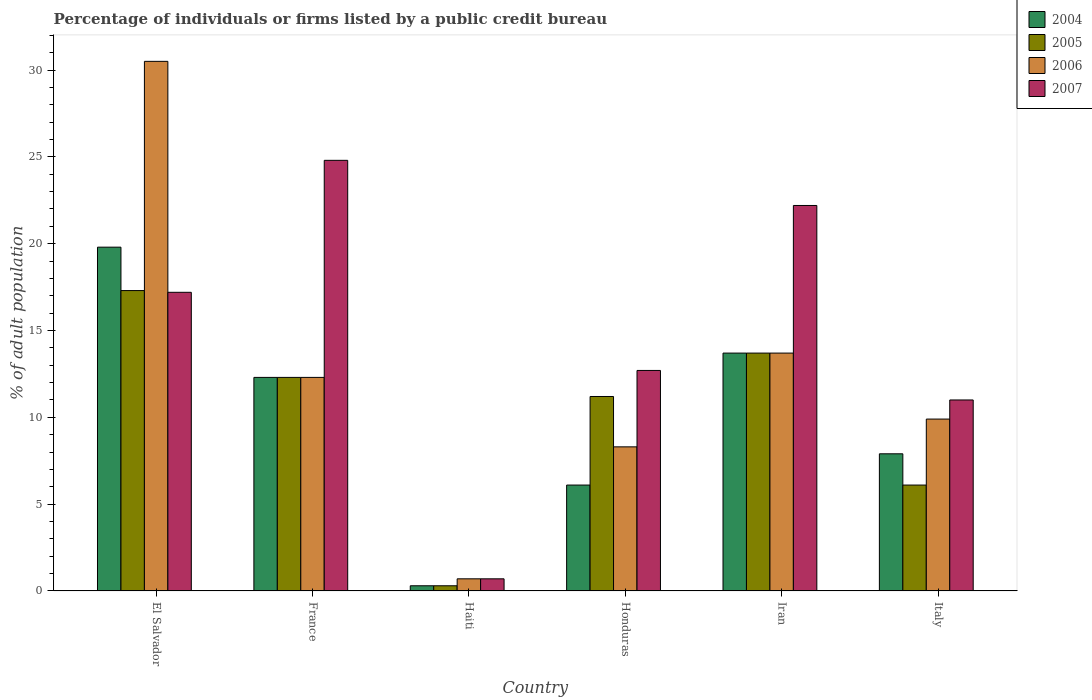How many different coloured bars are there?
Provide a short and direct response. 4. How many groups of bars are there?
Give a very brief answer. 6. What is the label of the 1st group of bars from the left?
Offer a very short reply. El Salvador. In how many cases, is the number of bars for a given country not equal to the number of legend labels?
Provide a short and direct response. 0. What is the percentage of population listed by a public credit bureau in 2004 in Iran?
Ensure brevity in your answer.  13.7. Across all countries, what is the maximum percentage of population listed by a public credit bureau in 2004?
Your answer should be very brief. 19.8. Across all countries, what is the minimum percentage of population listed by a public credit bureau in 2005?
Make the answer very short. 0.3. In which country was the percentage of population listed by a public credit bureau in 2004 maximum?
Give a very brief answer. El Salvador. In which country was the percentage of population listed by a public credit bureau in 2004 minimum?
Provide a succinct answer. Haiti. What is the total percentage of population listed by a public credit bureau in 2004 in the graph?
Make the answer very short. 60.1. What is the difference between the percentage of population listed by a public credit bureau in 2007 in Haiti and that in Honduras?
Your response must be concise. -12. What is the difference between the percentage of population listed by a public credit bureau in 2006 in Honduras and the percentage of population listed by a public credit bureau in 2007 in Italy?
Keep it short and to the point. -2.7. What is the average percentage of population listed by a public credit bureau in 2004 per country?
Provide a succinct answer. 10.02. What is the ratio of the percentage of population listed by a public credit bureau in 2004 in El Salvador to that in Iran?
Offer a terse response. 1.45. Is the difference between the percentage of population listed by a public credit bureau in 2007 in El Salvador and Haiti greater than the difference between the percentage of population listed by a public credit bureau in 2005 in El Salvador and Haiti?
Your response must be concise. No. What is the difference between the highest and the second highest percentage of population listed by a public credit bureau in 2006?
Ensure brevity in your answer.  -1.4. What is the difference between the highest and the lowest percentage of population listed by a public credit bureau in 2007?
Your answer should be very brief. 24.1. In how many countries, is the percentage of population listed by a public credit bureau in 2006 greater than the average percentage of population listed by a public credit bureau in 2006 taken over all countries?
Offer a very short reply. 2. What does the 2nd bar from the left in Haiti represents?
Keep it short and to the point. 2005. Is it the case that in every country, the sum of the percentage of population listed by a public credit bureau in 2007 and percentage of population listed by a public credit bureau in 2004 is greater than the percentage of population listed by a public credit bureau in 2005?
Give a very brief answer. Yes. How many bars are there?
Offer a terse response. 24. What is the difference between two consecutive major ticks on the Y-axis?
Provide a short and direct response. 5. Does the graph contain any zero values?
Your response must be concise. No. Does the graph contain grids?
Offer a very short reply. No. How many legend labels are there?
Your answer should be very brief. 4. What is the title of the graph?
Offer a terse response. Percentage of individuals or firms listed by a public credit bureau. What is the label or title of the Y-axis?
Your response must be concise. % of adult population. What is the % of adult population in 2004 in El Salvador?
Your answer should be compact. 19.8. What is the % of adult population of 2005 in El Salvador?
Offer a terse response. 17.3. What is the % of adult population of 2006 in El Salvador?
Provide a succinct answer. 30.5. What is the % of adult population in 2007 in El Salvador?
Your answer should be compact. 17.2. What is the % of adult population of 2004 in France?
Offer a very short reply. 12.3. What is the % of adult population in 2006 in France?
Provide a succinct answer. 12.3. What is the % of adult population in 2007 in France?
Your response must be concise. 24.8. What is the % of adult population in 2004 in Haiti?
Your response must be concise. 0.3. What is the % of adult population in 2006 in Haiti?
Your answer should be compact. 0.7. What is the % of adult population in 2007 in Haiti?
Offer a terse response. 0.7. What is the % of adult population in 2007 in Honduras?
Provide a short and direct response. 12.7. What is the % of adult population in 2004 in Iran?
Your response must be concise. 13.7. What is the % of adult population of 2007 in Iran?
Give a very brief answer. 22.2. What is the % of adult population in 2006 in Italy?
Your response must be concise. 9.9. Across all countries, what is the maximum % of adult population in 2004?
Provide a succinct answer. 19.8. Across all countries, what is the maximum % of adult population in 2005?
Offer a terse response. 17.3. Across all countries, what is the maximum % of adult population in 2006?
Ensure brevity in your answer.  30.5. Across all countries, what is the maximum % of adult population of 2007?
Provide a succinct answer. 24.8. Across all countries, what is the minimum % of adult population of 2004?
Give a very brief answer. 0.3. Across all countries, what is the minimum % of adult population of 2005?
Your answer should be very brief. 0.3. What is the total % of adult population in 2004 in the graph?
Provide a short and direct response. 60.1. What is the total % of adult population of 2005 in the graph?
Offer a very short reply. 60.9. What is the total % of adult population in 2006 in the graph?
Offer a very short reply. 75.4. What is the total % of adult population of 2007 in the graph?
Make the answer very short. 88.6. What is the difference between the % of adult population in 2004 in El Salvador and that in France?
Keep it short and to the point. 7.5. What is the difference between the % of adult population of 2005 in El Salvador and that in France?
Offer a very short reply. 5. What is the difference between the % of adult population in 2004 in El Salvador and that in Haiti?
Your response must be concise. 19.5. What is the difference between the % of adult population in 2006 in El Salvador and that in Haiti?
Give a very brief answer. 29.8. What is the difference between the % of adult population in 2007 in El Salvador and that in Haiti?
Offer a terse response. 16.5. What is the difference between the % of adult population in 2006 in El Salvador and that in Honduras?
Offer a very short reply. 22.2. What is the difference between the % of adult population of 2004 in El Salvador and that in Iran?
Offer a terse response. 6.1. What is the difference between the % of adult population in 2005 in El Salvador and that in Iran?
Give a very brief answer. 3.6. What is the difference between the % of adult population of 2006 in El Salvador and that in Iran?
Ensure brevity in your answer.  16.8. What is the difference between the % of adult population of 2007 in El Salvador and that in Iran?
Provide a short and direct response. -5. What is the difference between the % of adult population of 2005 in El Salvador and that in Italy?
Provide a short and direct response. 11.2. What is the difference between the % of adult population in 2006 in El Salvador and that in Italy?
Your answer should be compact. 20.6. What is the difference between the % of adult population of 2004 in France and that in Haiti?
Ensure brevity in your answer.  12. What is the difference between the % of adult population in 2005 in France and that in Haiti?
Offer a very short reply. 12. What is the difference between the % of adult population of 2006 in France and that in Haiti?
Your response must be concise. 11.6. What is the difference between the % of adult population of 2007 in France and that in Haiti?
Your response must be concise. 24.1. What is the difference between the % of adult population in 2004 in France and that in Honduras?
Offer a very short reply. 6.2. What is the difference between the % of adult population of 2005 in France and that in Honduras?
Keep it short and to the point. 1.1. What is the difference between the % of adult population of 2007 in France and that in Honduras?
Make the answer very short. 12.1. What is the difference between the % of adult population in 2007 in France and that in Iran?
Your response must be concise. 2.6. What is the difference between the % of adult population of 2004 in France and that in Italy?
Your response must be concise. 4.4. What is the difference between the % of adult population of 2006 in France and that in Italy?
Ensure brevity in your answer.  2.4. What is the difference between the % of adult population in 2004 in Haiti and that in Honduras?
Your answer should be very brief. -5.8. What is the difference between the % of adult population of 2007 in Haiti and that in Honduras?
Ensure brevity in your answer.  -12. What is the difference between the % of adult population in 2004 in Haiti and that in Iran?
Your response must be concise. -13.4. What is the difference between the % of adult population of 2005 in Haiti and that in Iran?
Ensure brevity in your answer.  -13.4. What is the difference between the % of adult population in 2007 in Haiti and that in Iran?
Provide a succinct answer. -21.5. What is the difference between the % of adult population in 2004 in Haiti and that in Italy?
Keep it short and to the point. -7.6. What is the difference between the % of adult population of 2006 in Haiti and that in Italy?
Provide a short and direct response. -9.2. What is the difference between the % of adult population of 2007 in Haiti and that in Italy?
Give a very brief answer. -10.3. What is the difference between the % of adult population in 2004 in Honduras and that in Iran?
Offer a terse response. -7.6. What is the difference between the % of adult population in 2006 in Honduras and that in Iran?
Ensure brevity in your answer.  -5.4. What is the difference between the % of adult population in 2006 in Honduras and that in Italy?
Keep it short and to the point. -1.6. What is the difference between the % of adult population in 2004 in El Salvador and the % of adult population in 2006 in France?
Make the answer very short. 7.5. What is the difference between the % of adult population in 2005 in El Salvador and the % of adult population in 2007 in France?
Offer a terse response. -7.5. What is the difference between the % of adult population of 2004 in El Salvador and the % of adult population of 2005 in Haiti?
Keep it short and to the point. 19.5. What is the difference between the % of adult population of 2004 in El Salvador and the % of adult population of 2006 in Haiti?
Offer a very short reply. 19.1. What is the difference between the % of adult population of 2004 in El Salvador and the % of adult population of 2007 in Haiti?
Ensure brevity in your answer.  19.1. What is the difference between the % of adult population in 2005 in El Salvador and the % of adult population in 2006 in Haiti?
Your answer should be very brief. 16.6. What is the difference between the % of adult population of 2006 in El Salvador and the % of adult population of 2007 in Haiti?
Provide a short and direct response. 29.8. What is the difference between the % of adult population in 2004 in El Salvador and the % of adult population in 2007 in Honduras?
Keep it short and to the point. 7.1. What is the difference between the % of adult population of 2005 in El Salvador and the % of adult population of 2006 in Honduras?
Offer a terse response. 9. What is the difference between the % of adult population in 2006 in El Salvador and the % of adult population in 2007 in Honduras?
Your response must be concise. 17.8. What is the difference between the % of adult population in 2004 in El Salvador and the % of adult population in 2006 in Iran?
Your answer should be compact. 6.1. What is the difference between the % of adult population in 2004 in El Salvador and the % of adult population in 2007 in Iran?
Ensure brevity in your answer.  -2.4. What is the difference between the % of adult population in 2005 in El Salvador and the % of adult population in 2006 in Iran?
Offer a terse response. 3.6. What is the difference between the % of adult population in 2005 in El Salvador and the % of adult population in 2007 in Iran?
Give a very brief answer. -4.9. What is the difference between the % of adult population in 2004 in El Salvador and the % of adult population in 2005 in Italy?
Offer a very short reply. 13.7. What is the difference between the % of adult population in 2004 in El Salvador and the % of adult population in 2006 in Italy?
Keep it short and to the point. 9.9. What is the difference between the % of adult population in 2004 in El Salvador and the % of adult population in 2007 in Italy?
Your response must be concise. 8.8. What is the difference between the % of adult population of 2005 in El Salvador and the % of adult population of 2007 in Italy?
Offer a very short reply. 6.3. What is the difference between the % of adult population of 2004 in France and the % of adult population of 2005 in Haiti?
Your answer should be very brief. 12. What is the difference between the % of adult population in 2004 in France and the % of adult population in 2006 in Haiti?
Ensure brevity in your answer.  11.6. What is the difference between the % of adult population of 2004 in France and the % of adult population of 2007 in Haiti?
Provide a short and direct response. 11.6. What is the difference between the % of adult population of 2005 in France and the % of adult population of 2006 in Haiti?
Your response must be concise. 11.6. What is the difference between the % of adult population of 2005 in France and the % of adult population of 2007 in Haiti?
Your response must be concise. 11.6. What is the difference between the % of adult population in 2004 in France and the % of adult population in 2006 in Honduras?
Give a very brief answer. 4. What is the difference between the % of adult population in 2006 in France and the % of adult population in 2007 in Honduras?
Provide a succinct answer. -0.4. What is the difference between the % of adult population of 2005 in France and the % of adult population of 2006 in Iran?
Your response must be concise. -1.4. What is the difference between the % of adult population of 2005 in France and the % of adult population of 2007 in Iran?
Offer a terse response. -9.9. What is the difference between the % of adult population of 2004 in France and the % of adult population of 2005 in Italy?
Provide a short and direct response. 6.2. What is the difference between the % of adult population in 2005 in France and the % of adult population in 2007 in Italy?
Your response must be concise. 1.3. What is the difference between the % of adult population of 2006 in France and the % of adult population of 2007 in Italy?
Your answer should be compact. 1.3. What is the difference between the % of adult population of 2004 in Haiti and the % of adult population of 2005 in Honduras?
Ensure brevity in your answer.  -10.9. What is the difference between the % of adult population of 2004 in Haiti and the % of adult population of 2006 in Honduras?
Your answer should be very brief. -8. What is the difference between the % of adult population of 2004 in Haiti and the % of adult population of 2007 in Honduras?
Provide a short and direct response. -12.4. What is the difference between the % of adult population in 2005 in Haiti and the % of adult population in 2006 in Honduras?
Provide a short and direct response. -8. What is the difference between the % of adult population of 2005 in Haiti and the % of adult population of 2007 in Honduras?
Keep it short and to the point. -12.4. What is the difference between the % of adult population of 2004 in Haiti and the % of adult population of 2005 in Iran?
Keep it short and to the point. -13.4. What is the difference between the % of adult population in 2004 in Haiti and the % of adult population in 2006 in Iran?
Ensure brevity in your answer.  -13.4. What is the difference between the % of adult population of 2004 in Haiti and the % of adult population of 2007 in Iran?
Provide a short and direct response. -21.9. What is the difference between the % of adult population of 2005 in Haiti and the % of adult population of 2007 in Iran?
Make the answer very short. -21.9. What is the difference between the % of adult population in 2006 in Haiti and the % of adult population in 2007 in Iran?
Give a very brief answer. -21.5. What is the difference between the % of adult population of 2004 in Haiti and the % of adult population of 2006 in Italy?
Keep it short and to the point. -9.6. What is the difference between the % of adult population of 2004 in Haiti and the % of adult population of 2007 in Italy?
Your answer should be very brief. -10.7. What is the difference between the % of adult population in 2004 in Honduras and the % of adult population in 2007 in Iran?
Keep it short and to the point. -16.1. What is the difference between the % of adult population in 2004 in Honduras and the % of adult population in 2007 in Italy?
Give a very brief answer. -4.9. What is the difference between the % of adult population of 2005 in Honduras and the % of adult population of 2006 in Italy?
Your answer should be compact. 1.3. What is the difference between the % of adult population in 2005 in Honduras and the % of adult population in 2007 in Italy?
Your answer should be compact. 0.2. What is the difference between the % of adult population of 2006 in Honduras and the % of adult population of 2007 in Italy?
Offer a terse response. -2.7. What is the difference between the % of adult population of 2005 in Iran and the % of adult population of 2007 in Italy?
Make the answer very short. 2.7. What is the average % of adult population of 2004 per country?
Provide a short and direct response. 10.02. What is the average % of adult population of 2005 per country?
Keep it short and to the point. 10.15. What is the average % of adult population of 2006 per country?
Your answer should be very brief. 12.57. What is the average % of adult population of 2007 per country?
Provide a short and direct response. 14.77. What is the difference between the % of adult population in 2004 and % of adult population in 2005 in El Salvador?
Make the answer very short. 2.5. What is the difference between the % of adult population of 2006 and % of adult population of 2007 in El Salvador?
Your answer should be compact. 13.3. What is the difference between the % of adult population in 2004 and % of adult population in 2005 in France?
Your answer should be very brief. 0. What is the difference between the % of adult population of 2004 and % of adult population of 2006 in France?
Your answer should be very brief. 0. What is the difference between the % of adult population in 2005 and % of adult population in 2006 in France?
Your answer should be very brief. 0. What is the difference between the % of adult population of 2005 and % of adult population of 2007 in France?
Give a very brief answer. -12.5. What is the difference between the % of adult population in 2006 and % of adult population in 2007 in France?
Make the answer very short. -12.5. What is the difference between the % of adult population of 2004 and % of adult population of 2007 in Haiti?
Make the answer very short. -0.4. What is the difference between the % of adult population of 2006 and % of adult population of 2007 in Haiti?
Make the answer very short. 0. What is the difference between the % of adult population in 2004 and % of adult population in 2005 in Honduras?
Give a very brief answer. -5.1. What is the difference between the % of adult population in 2004 and % of adult population in 2006 in Honduras?
Your answer should be very brief. -2.2. What is the difference between the % of adult population of 2004 and % of adult population of 2007 in Honduras?
Give a very brief answer. -6.6. What is the difference between the % of adult population of 2005 and % of adult population of 2006 in Honduras?
Offer a very short reply. 2.9. What is the difference between the % of adult population in 2004 and % of adult population in 2005 in Iran?
Your answer should be very brief. 0. What is the difference between the % of adult population in 2004 and % of adult population in 2007 in Iran?
Keep it short and to the point. -8.5. What is the difference between the % of adult population of 2005 and % of adult population of 2006 in Iran?
Make the answer very short. 0. What is the difference between the % of adult population of 2005 and % of adult population of 2007 in Iran?
Offer a very short reply. -8.5. What is the difference between the % of adult population of 2004 and % of adult population of 2005 in Italy?
Ensure brevity in your answer.  1.8. What is the difference between the % of adult population in 2004 and % of adult population in 2007 in Italy?
Your answer should be compact. -3.1. What is the difference between the % of adult population in 2005 and % of adult population in 2007 in Italy?
Keep it short and to the point. -4.9. What is the ratio of the % of adult population in 2004 in El Salvador to that in France?
Offer a very short reply. 1.61. What is the ratio of the % of adult population of 2005 in El Salvador to that in France?
Your response must be concise. 1.41. What is the ratio of the % of adult population of 2006 in El Salvador to that in France?
Keep it short and to the point. 2.48. What is the ratio of the % of adult population of 2007 in El Salvador to that in France?
Give a very brief answer. 0.69. What is the ratio of the % of adult population in 2004 in El Salvador to that in Haiti?
Ensure brevity in your answer.  66. What is the ratio of the % of adult population in 2005 in El Salvador to that in Haiti?
Provide a succinct answer. 57.67. What is the ratio of the % of adult population in 2006 in El Salvador to that in Haiti?
Ensure brevity in your answer.  43.57. What is the ratio of the % of adult population of 2007 in El Salvador to that in Haiti?
Ensure brevity in your answer.  24.57. What is the ratio of the % of adult population in 2004 in El Salvador to that in Honduras?
Ensure brevity in your answer.  3.25. What is the ratio of the % of adult population of 2005 in El Salvador to that in Honduras?
Give a very brief answer. 1.54. What is the ratio of the % of adult population of 2006 in El Salvador to that in Honduras?
Keep it short and to the point. 3.67. What is the ratio of the % of adult population in 2007 in El Salvador to that in Honduras?
Provide a short and direct response. 1.35. What is the ratio of the % of adult population of 2004 in El Salvador to that in Iran?
Keep it short and to the point. 1.45. What is the ratio of the % of adult population of 2005 in El Salvador to that in Iran?
Your answer should be very brief. 1.26. What is the ratio of the % of adult population in 2006 in El Salvador to that in Iran?
Provide a succinct answer. 2.23. What is the ratio of the % of adult population in 2007 in El Salvador to that in Iran?
Keep it short and to the point. 0.77. What is the ratio of the % of adult population of 2004 in El Salvador to that in Italy?
Offer a very short reply. 2.51. What is the ratio of the % of adult population in 2005 in El Salvador to that in Italy?
Your answer should be very brief. 2.84. What is the ratio of the % of adult population of 2006 in El Salvador to that in Italy?
Your answer should be very brief. 3.08. What is the ratio of the % of adult population in 2007 in El Salvador to that in Italy?
Give a very brief answer. 1.56. What is the ratio of the % of adult population of 2006 in France to that in Haiti?
Your response must be concise. 17.57. What is the ratio of the % of adult population in 2007 in France to that in Haiti?
Your answer should be compact. 35.43. What is the ratio of the % of adult population in 2004 in France to that in Honduras?
Provide a short and direct response. 2.02. What is the ratio of the % of adult population of 2005 in France to that in Honduras?
Offer a very short reply. 1.1. What is the ratio of the % of adult population in 2006 in France to that in Honduras?
Provide a succinct answer. 1.48. What is the ratio of the % of adult population in 2007 in France to that in Honduras?
Provide a short and direct response. 1.95. What is the ratio of the % of adult population in 2004 in France to that in Iran?
Your answer should be very brief. 0.9. What is the ratio of the % of adult population in 2005 in France to that in Iran?
Make the answer very short. 0.9. What is the ratio of the % of adult population in 2006 in France to that in Iran?
Offer a very short reply. 0.9. What is the ratio of the % of adult population in 2007 in France to that in Iran?
Ensure brevity in your answer.  1.12. What is the ratio of the % of adult population in 2004 in France to that in Italy?
Ensure brevity in your answer.  1.56. What is the ratio of the % of adult population in 2005 in France to that in Italy?
Give a very brief answer. 2.02. What is the ratio of the % of adult population of 2006 in France to that in Italy?
Keep it short and to the point. 1.24. What is the ratio of the % of adult population in 2007 in France to that in Italy?
Ensure brevity in your answer.  2.25. What is the ratio of the % of adult population in 2004 in Haiti to that in Honduras?
Your answer should be very brief. 0.05. What is the ratio of the % of adult population in 2005 in Haiti to that in Honduras?
Give a very brief answer. 0.03. What is the ratio of the % of adult population of 2006 in Haiti to that in Honduras?
Make the answer very short. 0.08. What is the ratio of the % of adult population of 2007 in Haiti to that in Honduras?
Provide a succinct answer. 0.06. What is the ratio of the % of adult population in 2004 in Haiti to that in Iran?
Ensure brevity in your answer.  0.02. What is the ratio of the % of adult population of 2005 in Haiti to that in Iran?
Your answer should be very brief. 0.02. What is the ratio of the % of adult population in 2006 in Haiti to that in Iran?
Keep it short and to the point. 0.05. What is the ratio of the % of adult population of 2007 in Haiti to that in Iran?
Provide a succinct answer. 0.03. What is the ratio of the % of adult population of 2004 in Haiti to that in Italy?
Keep it short and to the point. 0.04. What is the ratio of the % of adult population in 2005 in Haiti to that in Italy?
Your answer should be very brief. 0.05. What is the ratio of the % of adult population of 2006 in Haiti to that in Italy?
Provide a short and direct response. 0.07. What is the ratio of the % of adult population of 2007 in Haiti to that in Italy?
Provide a short and direct response. 0.06. What is the ratio of the % of adult population in 2004 in Honduras to that in Iran?
Your answer should be very brief. 0.45. What is the ratio of the % of adult population of 2005 in Honduras to that in Iran?
Offer a very short reply. 0.82. What is the ratio of the % of adult population of 2006 in Honduras to that in Iran?
Offer a very short reply. 0.61. What is the ratio of the % of adult population of 2007 in Honduras to that in Iran?
Ensure brevity in your answer.  0.57. What is the ratio of the % of adult population of 2004 in Honduras to that in Italy?
Ensure brevity in your answer.  0.77. What is the ratio of the % of adult population of 2005 in Honduras to that in Italy?
Your answer should be very brief. 1.84. What is the ratio of the % of adult population in 2006 in Honduras to that in Italy?
Give a very brief answer. 0.84. What is the ratio of the % of adult population in 2007 in Honduras to that in Italy?
Your response must be concise. 1.15. What is the ratio of the % of adult population in 2004 in Iran to that in Italy?
Your response must be concise. 1.73. What is the ratio of the % of adult population in 2005 in Iran to that in Italy?
Your answer should be very brief. 2.25. What is the ratio of the % of adult population in 2006 in Iran to that in Italy?
Provide a short and direct response. 1.38. What is the ratio of the % of adult population in 2007 in Iran to that in Italy?
Your answer should be very brief. 2.02. What is the difference between the highest and the second highest % of adult population in 2007?
Offer a very short reply. 2.6. What is the difference between the highest and the lowest % of adult population in 2006?
Offer a very short reply. 29.8. What is the difference between the highest and the lowest % of adult population of 2007?
Offer a very short reply. 24.1. 